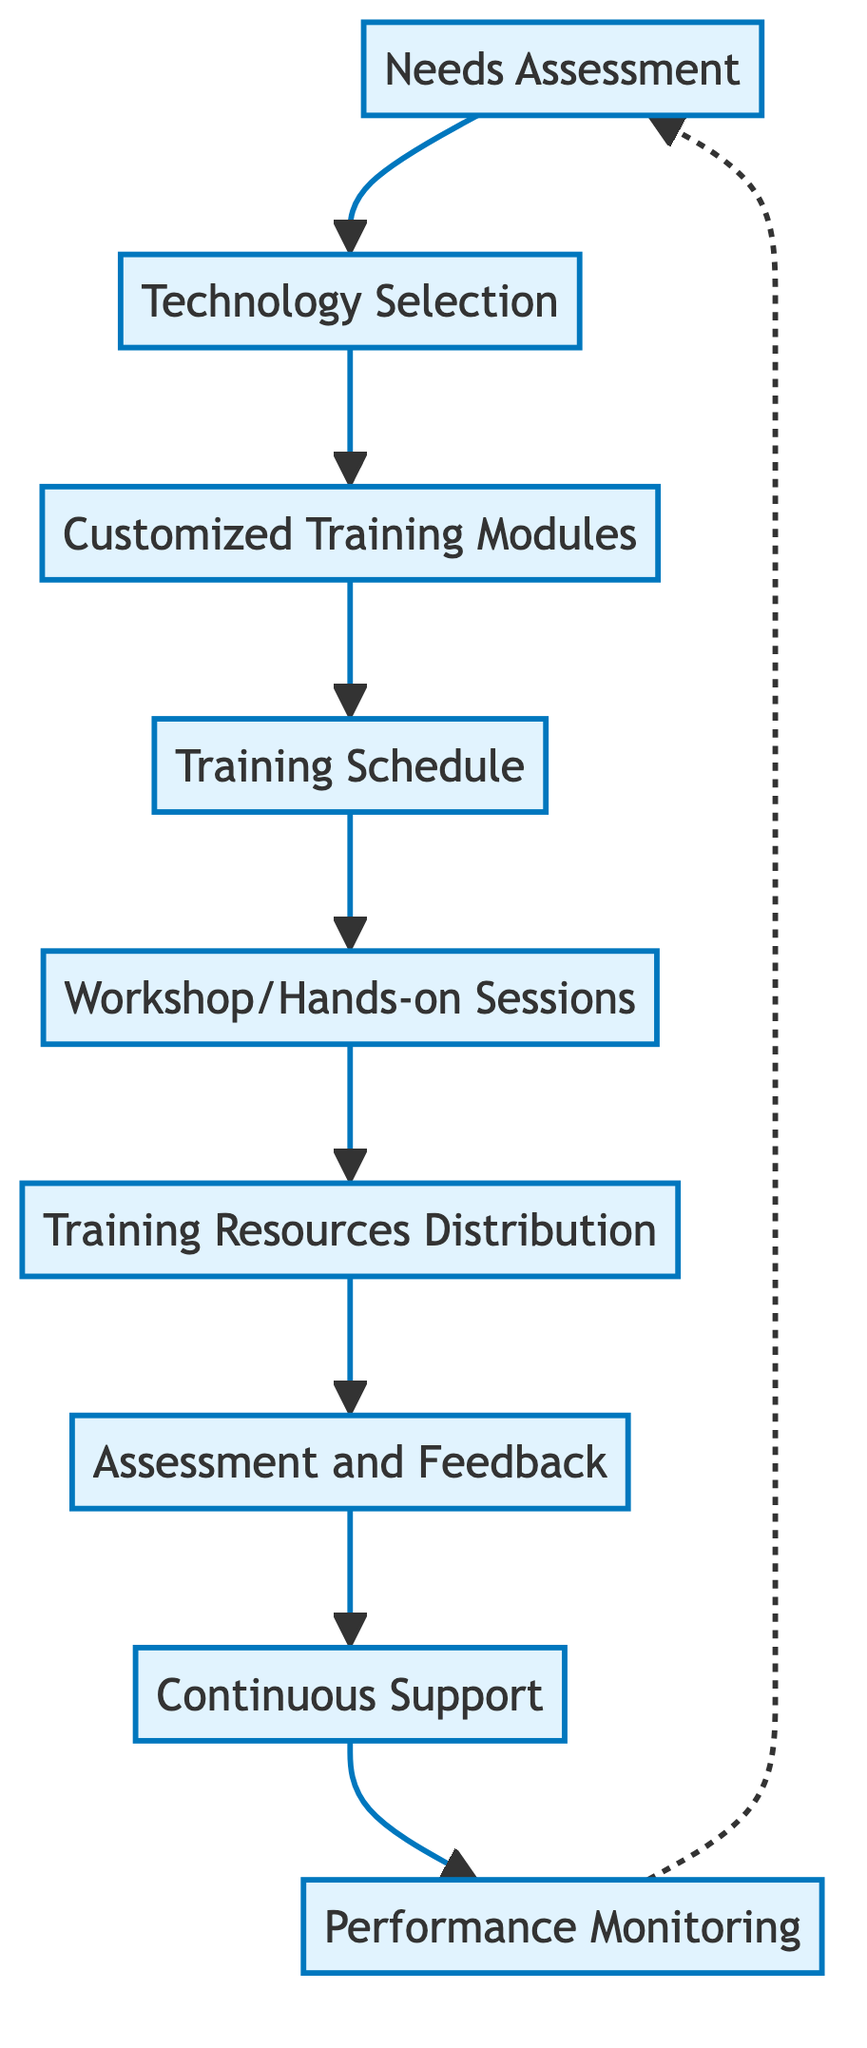What is the first step in the process? The first step in the flow chart is labeled as "Needs Assessment," which is identified at the top of the diagram.
Answer: Needs Assessment How many total nodes are in the flow chart? By counting each node displayed in the diagram, we find there are nine distinct nodes linked in the process flow.
Answer: 9 What is the last step in this process? The last step is labeled "Performance Monitoring," which is at the bottom of the flow chart.
Answer: Performance Monitoring Which two steps are linked directly before "Assessment and Feedback"? The steps "Training Resources Distribution" and "Workshop/Hands-on Sessions" are the two steps leading directly into "Assessment and Feedback" based on the flow direction in the diagram.
Answer: Workshop/Hands-on Sessions; Training Resources Distribution How does the flow of information between “Technology Selection” and “Customized Training Modules” occur? The flow moves directly from "Technology Selection" to "Customized Training Modules," indicating that once the technology is selected, customized training can be developed based on the chosen technology.
Answer: Directly What is the relationship between "Continuous Support" and "Training Resources Distribution"? "Continuous Support" follows "Assessment and Feedback" and does not directly connect to "Training Resources Distribution," but rather is part of a sequential process that builds upon the learned resources, ensuring lasting implementation and support of the technology.
Answer: Sequential process What role does the “Workshop/Hands-on Sessions” play in the training process? "Workshop/Hands-on Sessions" serves as a practical implementation stage where staff actively engage with the technology, which displays the importance of hands-on experience in the overall training process design.
Answer: Practical implementation stage What is the feedback mechanism in this process? The feedback mechanism is indicated at "Assessment and Feedback," where evaluations assess staff understanding and collect feedback to identify further training needs, thus serving to refine the training process continuously.
Answer: Evaluation and refinement process What type of support is offered after the training sessions? Ongoing technical support is provided to ensure that staff can tackle any challenges faced when using the new technology within the geriatric care context.
Answer: Ongoing technical support 